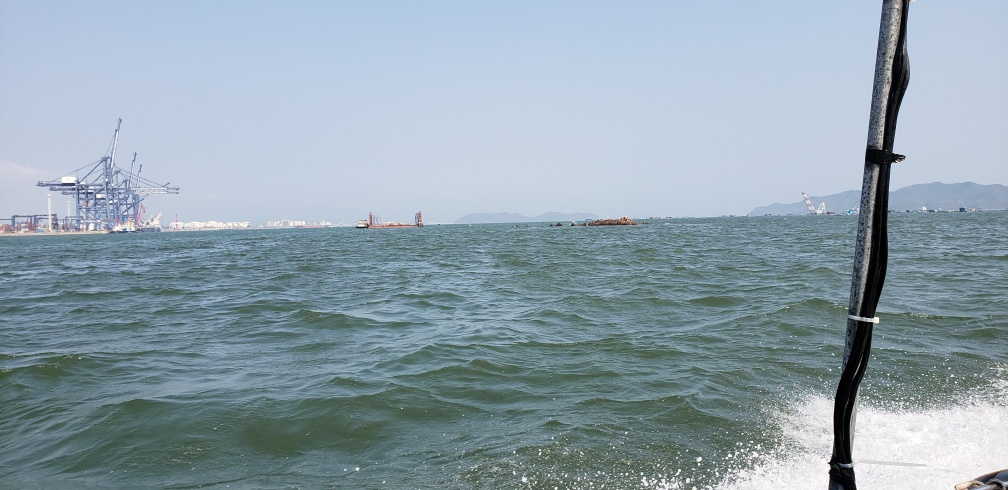What structures are visible on the horizon? Along the horizon, you can see what appear to be cranes typical of a shipping port. The structures' tall frames suggest a busy industrial area, likely facilitating maritime trade. 